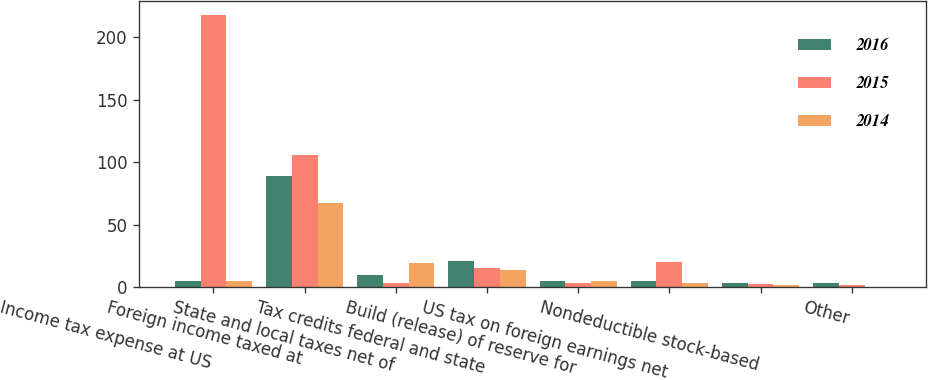<chart> <loc_0><loc_0><loc_500><loc_500><stacked_bar_chart><ecel><fcel>Income tax expense at US<fcel>Foreign income taxed at<fcel>State and local taxes net of<fcel>Tax credits federal and state<fcel>Build (release) of reserve for<fcel>US tax on foreign earnings net<fcel>Nondeductible stock-based<fcel>Other<nl><fcel>2016<fcel>4.95<fcel>88.6<fcel>9.7<fcel>21.3<fcel>4.6<fcel>5.1<fcel>3.6<fcel>3<nl><fcel>2015<fcel>217.8<fcel>105.8<fcel>3.1<fcel>15.7<fcel>3.3<fcel>20.5<fcel>2.3<fcel>2<nl><fcel>2014<fcel>4.95<fcel>67.1<fcel>19.3<fcel>13.5<fcel>4.8<fcel>3.1<fcel>2.1<fcel>0.4<nl></chart> 